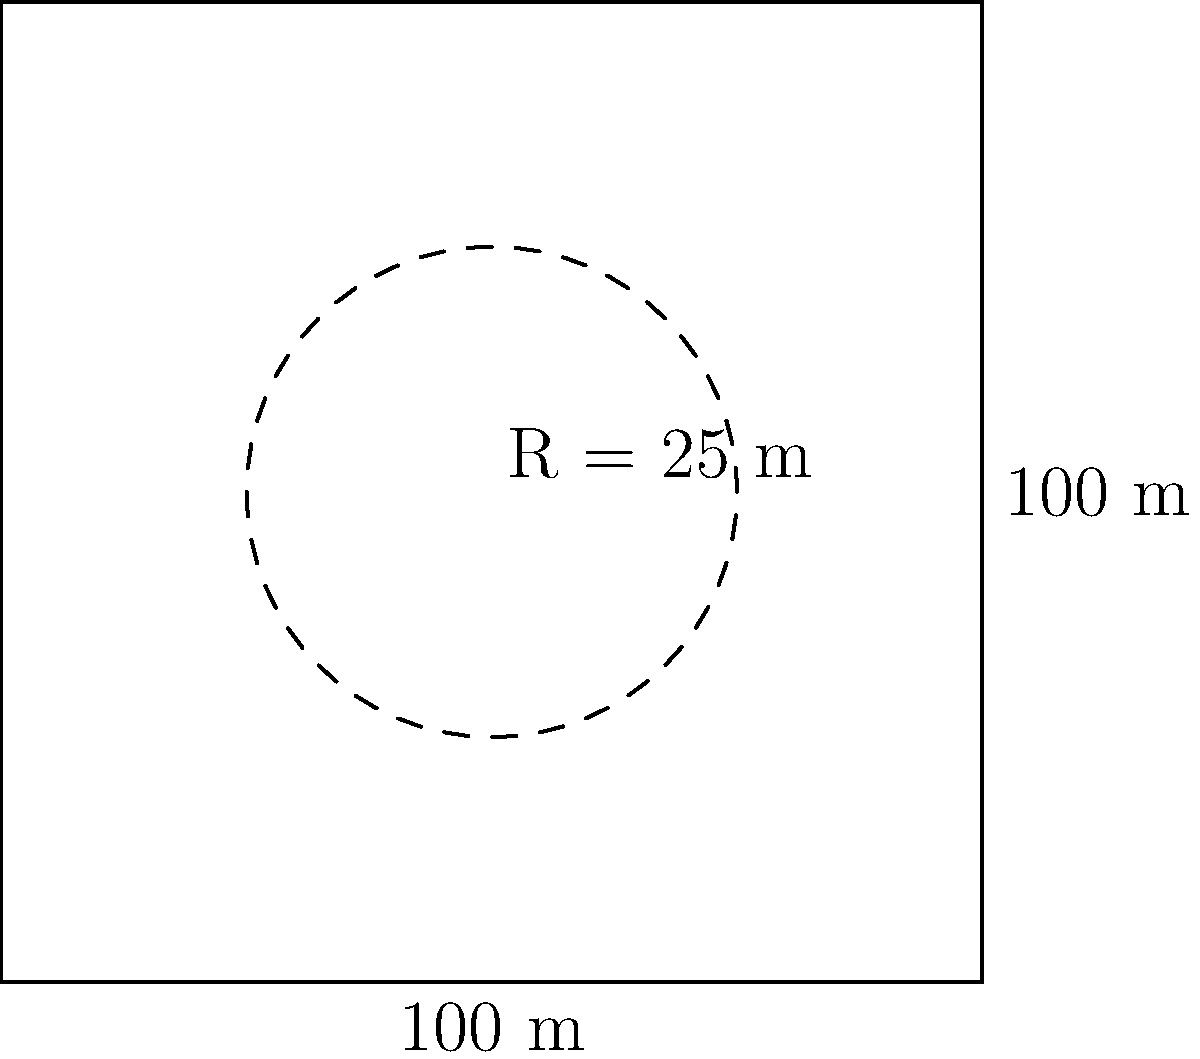A nuclear power plant's containment structure has a square base with sides measuring 100 meters. Inside this structure, there's a circular reactor chamber with a radius of 25 meters. What is the total perimeter of the containment structure, including both the outer square and the inner circle? Round your answer to the nearest meter. To solve this problem, we need to calculate the perimeter of both the square outer structure and the circular inner chamber, then add them together.

1. Perimeter of the square containment structure:
   $P_{square} = 4 \times \text{side length}$
   $P_{square} = 4 \times 100 \text{ m} = 400 \text{ m}$

2. Circumference of the circular reactor chamber:
   $C_{circle} = 2\pi r$
   $C_{circle} = 2 \times \pi \times 25 \text{ m}$
   $C_{circle} = 50\pi \text{ m} \approx 157.08 \text{ m}$

3. Total perimeter:
   $P_{total} = P_{square} + C_{circle}$
   $P_{total} = 400 \text{ m} + 157.08 \text{ m} = 557.08 \text{ m}$

4. Rounding to the nearest meter:
   $557.08 \text{ m} \approx 557 \text{ m}$

Therefore, the total perimeter of the containment structure, including both the outer square and the inner circle, is approximately 557 meters.
Answer: 557 meters 